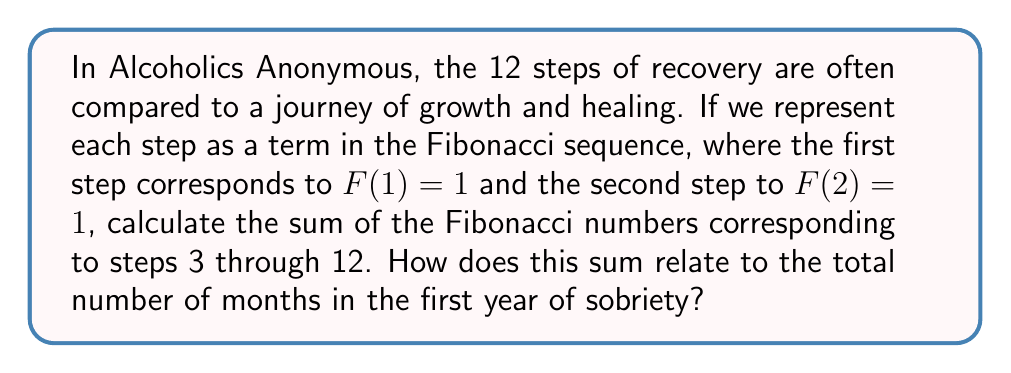Give your solution to this math problem. Let's approach this step-by-step:

1) First, let's recall the Fibonacci sequence:
   F(1) = 1, F(2) = 1, and for n > 2, F(n) = F(n-1) + F(n-2)

2) We need to calculate F(3) through F(12):
   F(3) = 1 + 1 = 2
   F(4) = 2 + 1 = 3
   F(5) = 3 + 2 = 5
   F(6) = 5 + 3 = 8
   F(7) = 8 + 5 = 13
   F(8) = 13 + 8 = 21
   F(9) = 21 + 13 = 34
   F(10) = 34 + 21 = 55
   F(11) = 55 + 34 = 89
   F(12) = 89 + 55 = 144

3) Now, we need to sum these values:
   $$\sum_{n=3}^{12} F(n) = 2 + 3 + 5 + 8 + 13 + 21 + 34 + 55 + 89 + 144 = 374$$

4) To relate this to the first year of sobriety:
   There are 12 months in a year.
   The sum we calculated (374) is 31 times 12 (with a remainder of 2).
   
5) This can be interpreted as each month of the first year of sobriety (12 in total) containing approximately 31 days of growth and healing (represented by the Fibonacci sum divided by 12).

This analogy shows how the growth in recovery (represented by the increasing Fibonacci numbers) accumulates significantly over the course of a year, with each step building on the previous ones.
Answer: The sum of the Fibonacci numbers corresponding to steps 3 through 12 is 374. This sum is approximately 31 times the number of months in a year (12), suggesting that each month in the first year of sobriety represents about 31 units of cumulative growth and healing in the recovery process. 